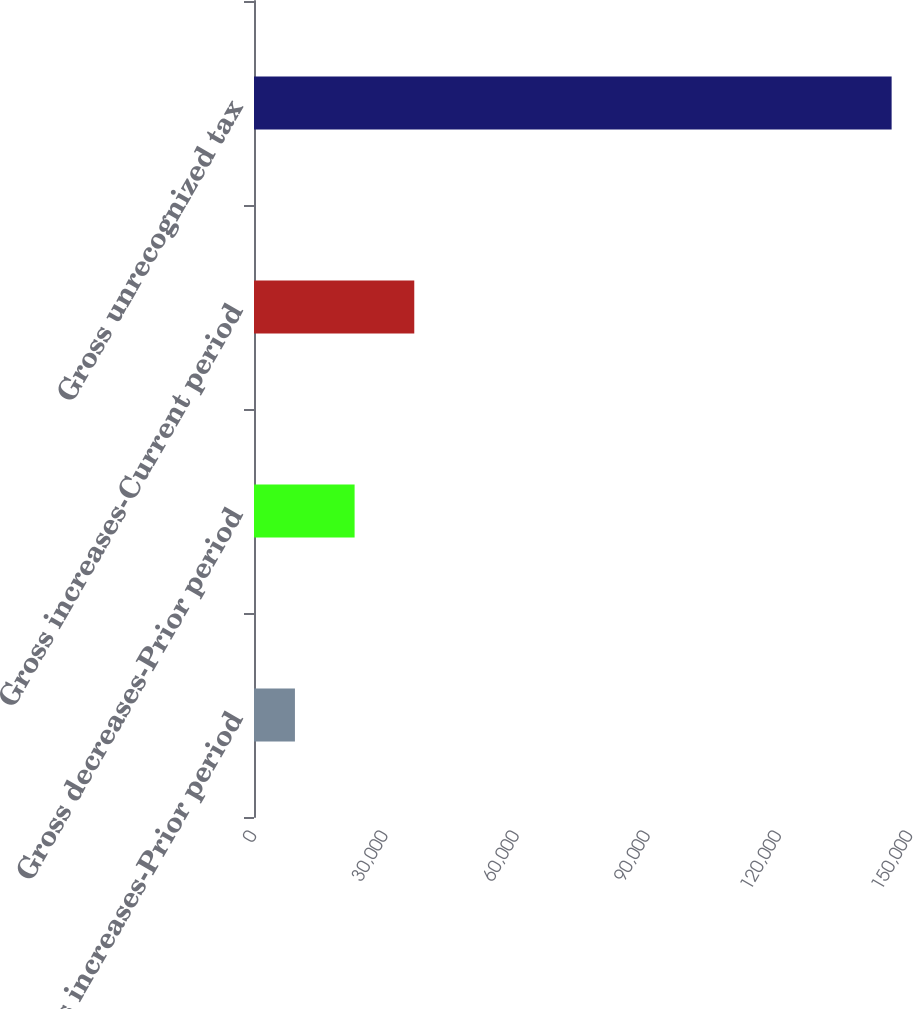Convert chart to OTSL. <chart><loc_0><loc_0><loc_500><loc_500><bar_chart><fcel>Gross increases-Prior period<fcel>Gross decreases-Prior period<fcel>Gross increases-Current period<fcel>Gross unrecognized tax<nl><fcel>9360<fcel>23003.9<fcel>36647.8<fcel>145799<nl></chart> 